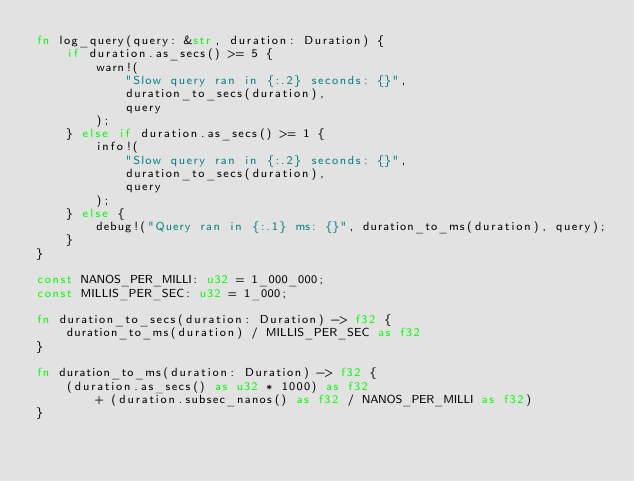Convert code to text. <code><loc_0><loc_0><loc_500><loc_500><_Rust_>fn log_query(query: &str, duration: Duration) {
    if duration.as_secs() >= 5 {
        warn!(
            "Slow query ran in {:.2} seconds: {}",
            duration_to_secs(duration),
            query
        );
    } else if duration.as_secs() >= 1 {
        info!(
            "Slow query ran in {:.2} seconds: {}",
            duration_to_secs(duration),
            query
        );
    } else {
        debug!("Query ran in {:.1} ms: {}", duration_to_ms(duration), query);
    }
}

const NANOS_PER_MILLI: u32 = 1_000_000;
const MILLIS_PER_SEC: u32 = 1_000;

fn duration_to_secs(duration: Duration) -> f32 {
    duration_to_ms(duration) / MILLIS_PER_SEC as f32
}

fn duration_to_ms(duration: Duration) -> f32 {
    (duration.as_secs() as u32 * 1000) as f32
        + (duration.subsec_nanos() as f32 / NANOS_PER_MILLI as f32)
}
</code> 